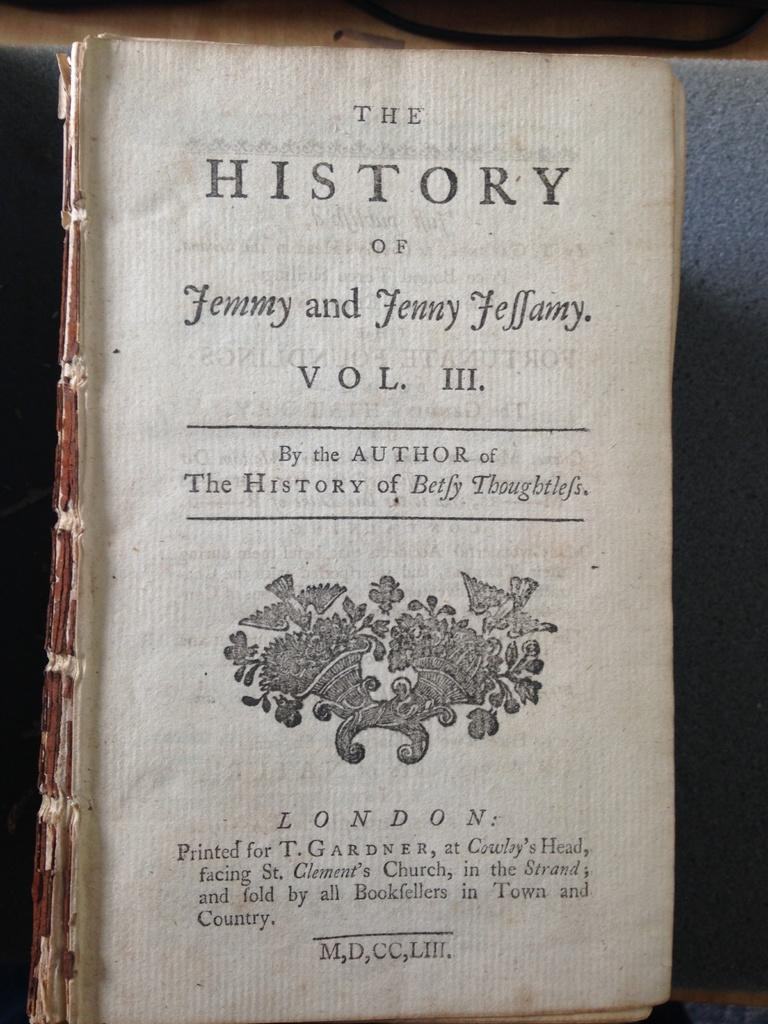<image>
Relay a brief, clear account of the picture shown. A book by the author of The History of Betfy Thoughtlefs is missing its cover. 